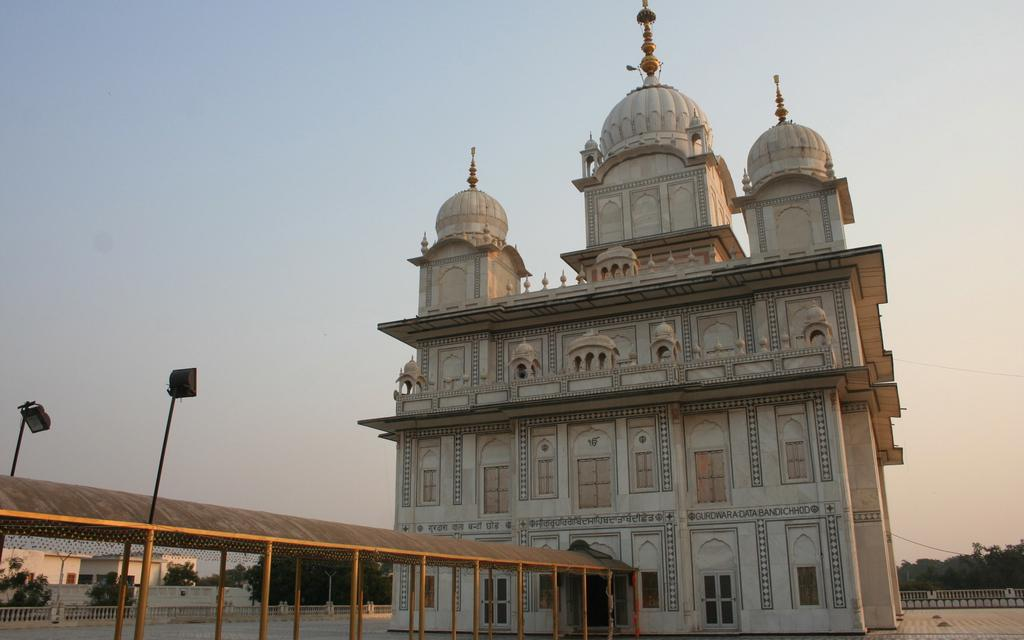What type of structure is visible in the image? There is a building in the image. What is located in front of the building? There is a path in front of the building. What is above the path? There is a roof above the path. What can be seen in the background of the image? There are trees and the sky visible in the background of the image. What type of cushion is being used by the pets in the image? There are no pets or cushions present in the image. What holiday is being celebrated in the image? There is no indication of a holiday being celebrated in the image. 